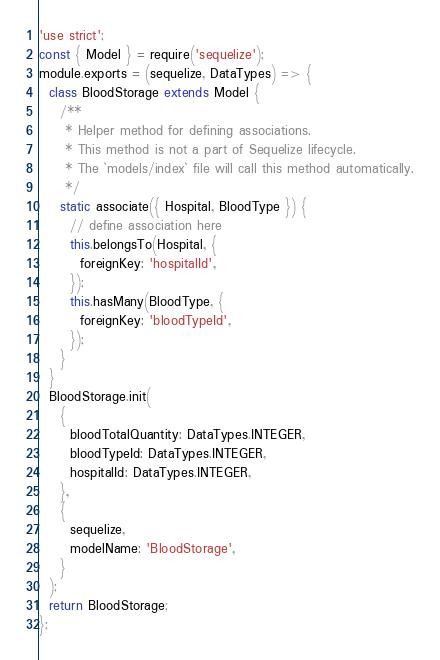<code> <loc_0><loc_0><loc_500><loc_500><_JavaScript_>'use strict';
const { Model } = require('sequelize');
module.exports = (sequelize, DataTypes) => {
  class BloodStorage extends Model {
    /**
     * Helper method for defining associations.
     * This method is not a part of Sequelize lifecycle.
     * The `models/index` file will call this method automatically.
     */
    static associate({ Hospital, BloodType }) {
      // define association here
      this.belongsTo(Hospital, {
        foreignKey: 'hospitalId',
      });
      this.hasMany(BloodType, {
        foreignKey: 'bloodTypeId',
      });
    }
  }
  BloodStorage.init(
    {
      bloodTotalQuantity: DataTypes.INTEGER,
      bloodTypeId: DataTypes.INTEGER,
      hospitalId: DataTypes.INTEGER,
    },
    {
      sequelize,
      modelName: 'BloodStorage',
    }
  );
  return BloodStorage;
};
</code> 